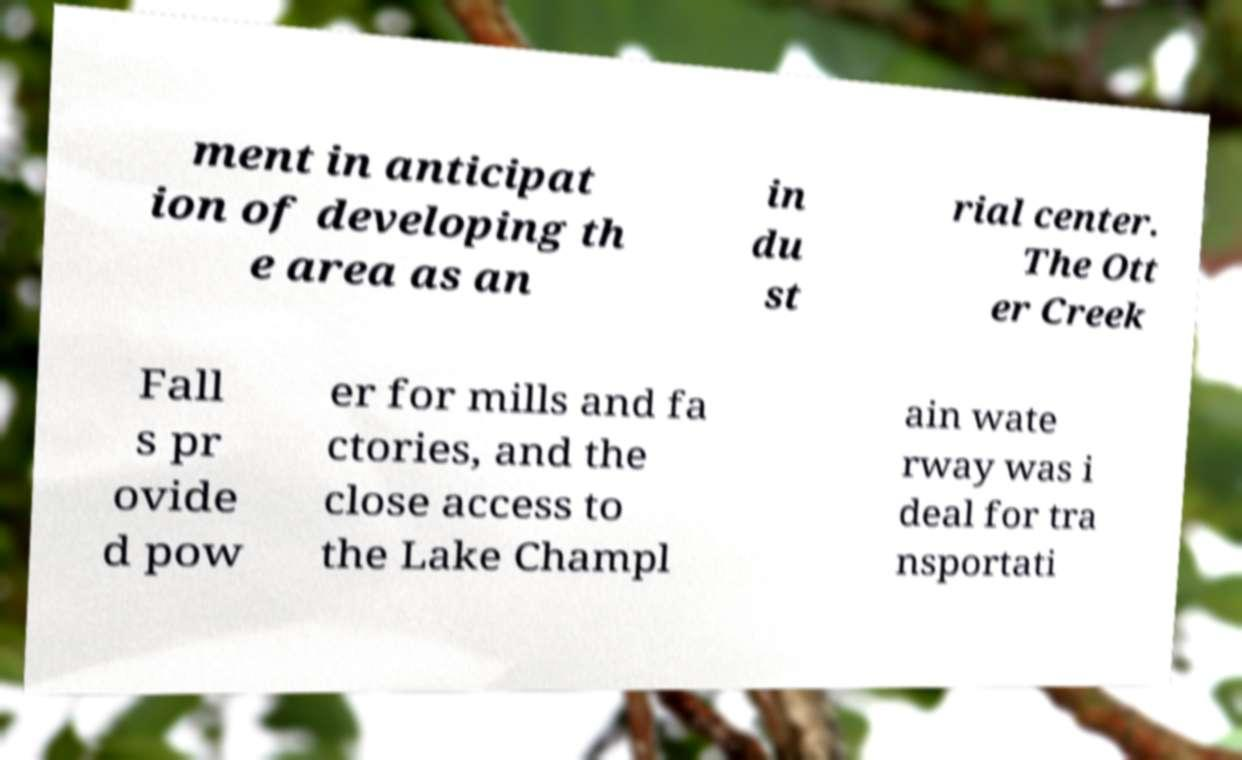Please identify and transcribe the text found in this image. ment in anticipat ion of developing th e area as an in du st rial center. The Ott er Creek Fall s pr ovide d pow er for mills and fa ctories, and the close access to the Lake Champl ain wate rway was i deal for tra nsportati 